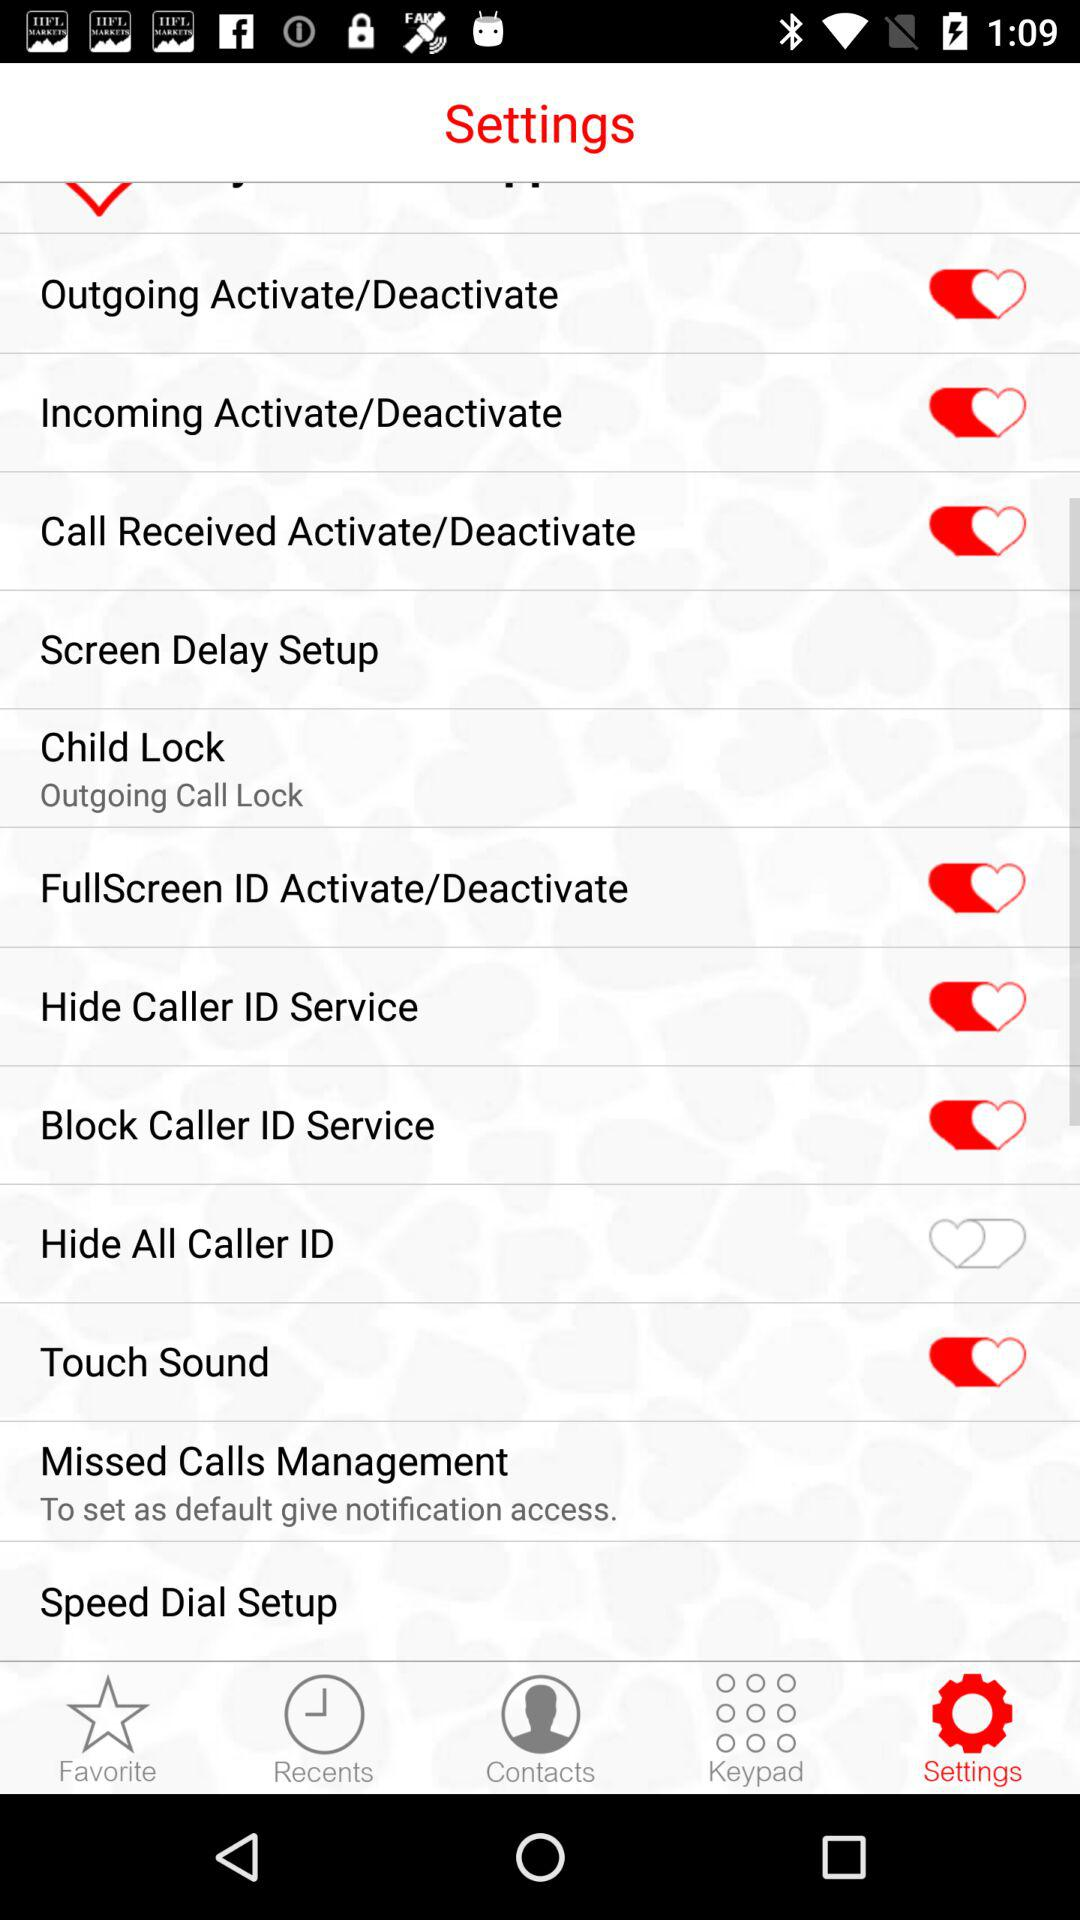What is the status of "Hide All Caller ID"? The status is "off". 